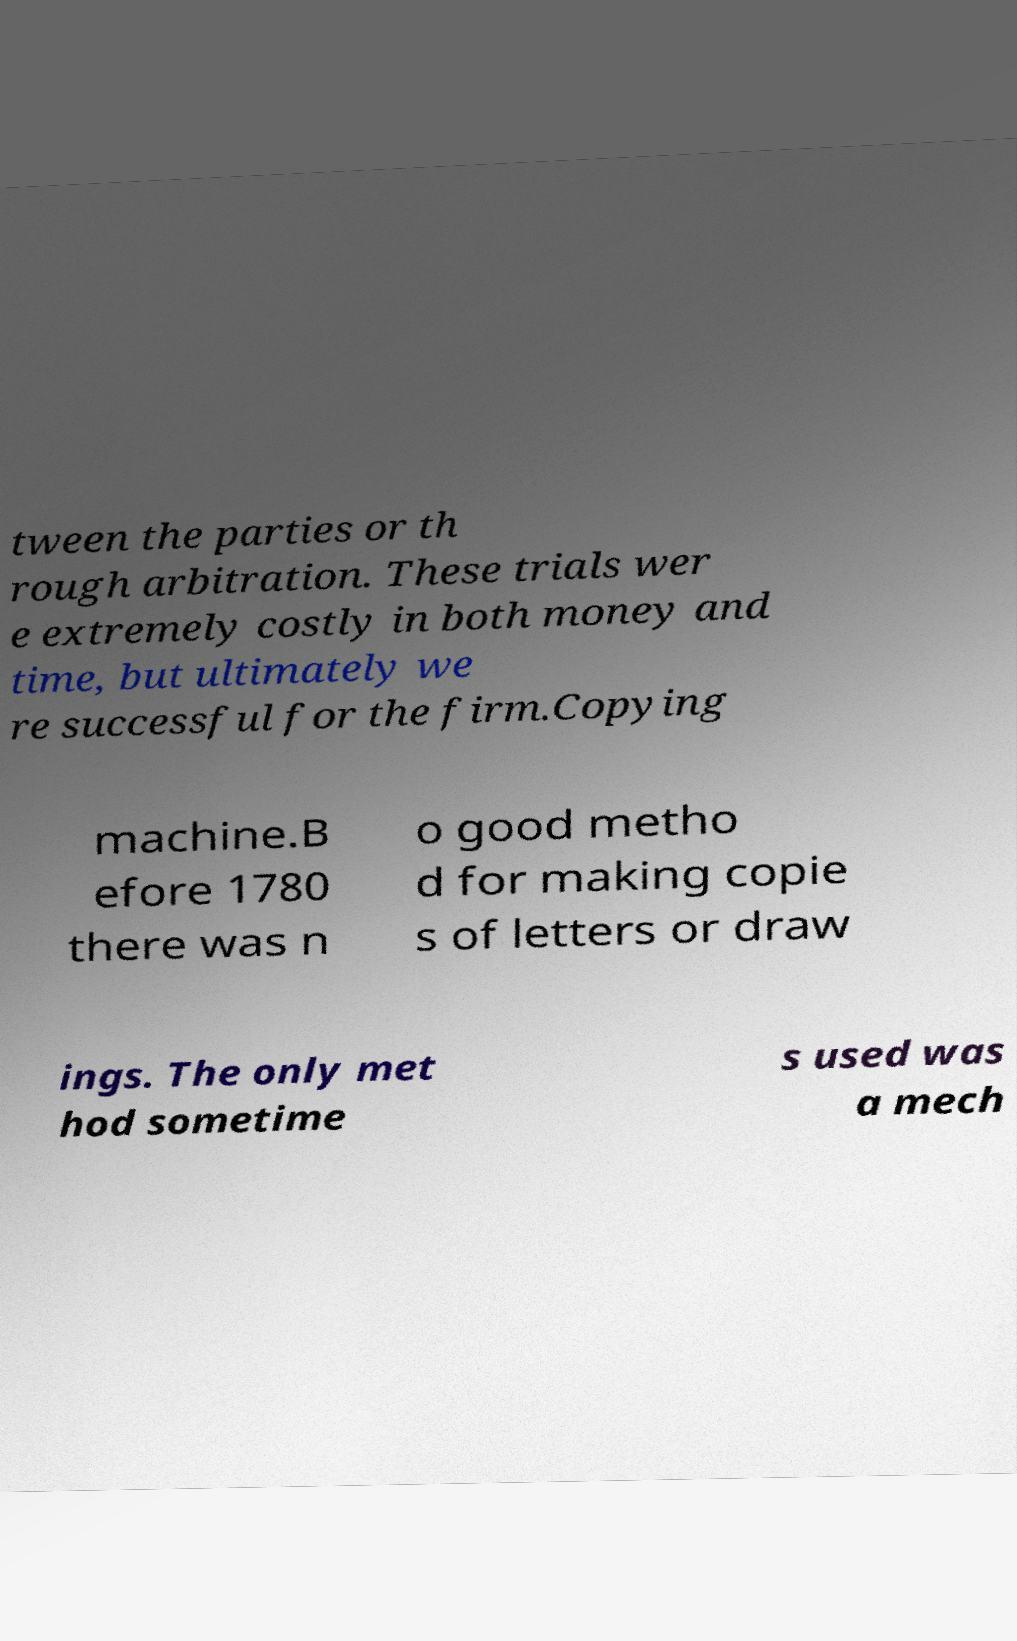What messages or text are displayed in this image? I need them in a readable, typed format. tween the parties or th rough arbitration. These trials wer e extremely costly in both money and time, but ultimately we re successful for the firm.Copying machine.B efore 1780 there was n o good metho d for making copie s of letters or draw ings. The only met hod sometime s used was a mech 